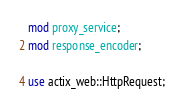<code> <loc_0><loc_0><loc_500><loc_500><_Rust_>mod proxy_service;
mod response_encoder;

use actix_web::HttpRequest;
</code> 